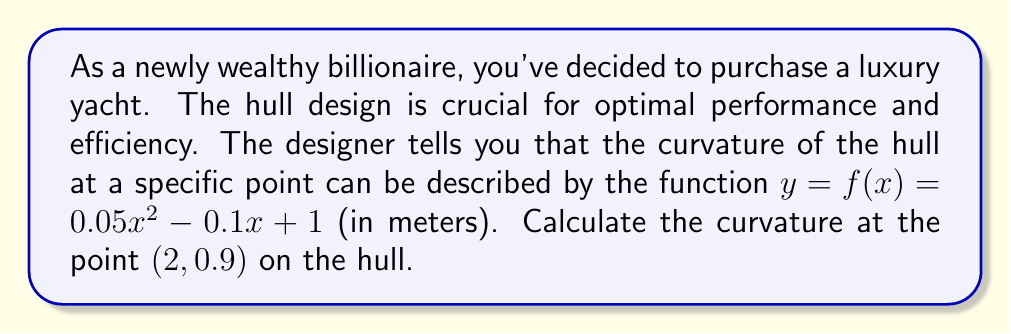Could you help me with this problem? To calculate the curvature of the yacht's hull at the given point, we'll follow these steps:

1. Recall the formula for curvature ($\kappa$) of a function $y = f(x)$:

   $$\kappa = \frac{|f''(x)|}{(1 + [f'(x)]^2)^{3/2}}$$

2. Find the first derivative $f'(x)$:
   $$f'(x) = 0.1x - 0.1$$

3. Find the second derivative $f''(x)$:
   $$f''(x) = 0.1$$

4. Evaluate $f'(x)$ at $x = 2$:
   $$f'(2) = 0.1(2) - 0.1 = 0.1$$

5. Now, let's substitute these values into the curvature formula:
   $$\kappa = \frac{|0.1|}{(1 + [0.1]^2)^{3/2}}$$

6. Simplify:
   $$\kappa = \frac{0.1}{(1 + 0.01)^{3/2}} = \frac{0.1}{(1.01)^{3/2}}$$

7. Calculate the final result:
   $$\kappa \approx 0.0990 \text{ m}^{-1}$$

The curvature is approximately 0.0990 m⁻¹ at the point (2, 0.9) on the yacht's hull.
Answer: $0.0990 \text{ m}^{-1}$ 